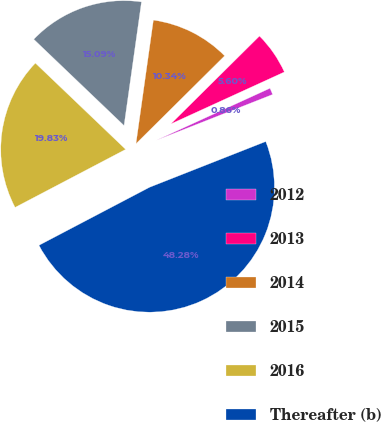Convert chart. <chart><loc_0><loc_0><loc_500><loc_500><pie_chart><fcel>2012<fcel>2013<fcel>2014<fcel>2015<fcel>2016<fcel>Thereafter (b)<nl><fcel>0.86%<fcel>5.6%<fcel>10.34%<fcel>15.09%<fcel>19.83%<fcel>48.28%<nl></chart> 